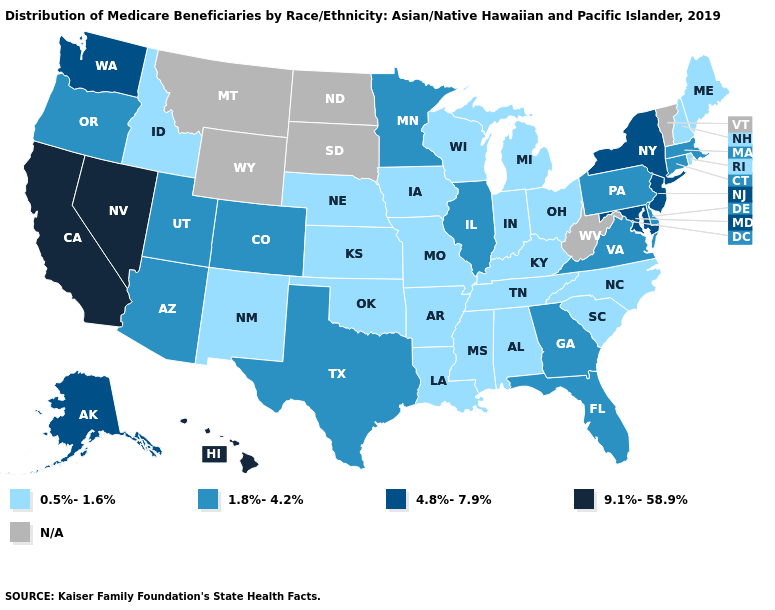Does Minnesota have the highest value in the MidWest?
Write a very short answer. Yes. Does the map have missing data?
Concise answer only. Yes. What is the highest value in states that border Indiana?
Short answer required. 1.8%-4.2%. What is the value of Delaware?
Keep it brief. 1.8%-4.2%. What is the lowest value in the West?
Keep it brief. 0.5%-1.6%. Does Nevada have the highest value in the USA?
Give a very brief answer. Yes. Does New Mexico have the lowest value in the USA?
Answer briefly. Yes. What is the highest value in states that border Kansas?
Keep it brief. 1.8%-4.2%. Does North Carolina have the lowest value in the South?
Write a very short answer. Yes. What is the highest value in states that border Vermont?
Give a very brief answer. 4.8%-7.9%. What is the value of Ohio?
Concise answer only. 0.5%-1.6%. What is the highest value in the Northeast ?
Concise answer only. 4.8%-7.9%. Among the states that border Illinois , which have the lowest value?
Concise answer only. Indiana, Iowa, Kentucky, Missouri, Wisconsin. Name the states that have a value in the range N/A?
Answer briefly. Montana, North Dakota, South Dakota, Vermont, West Virginia, Wyoming. 